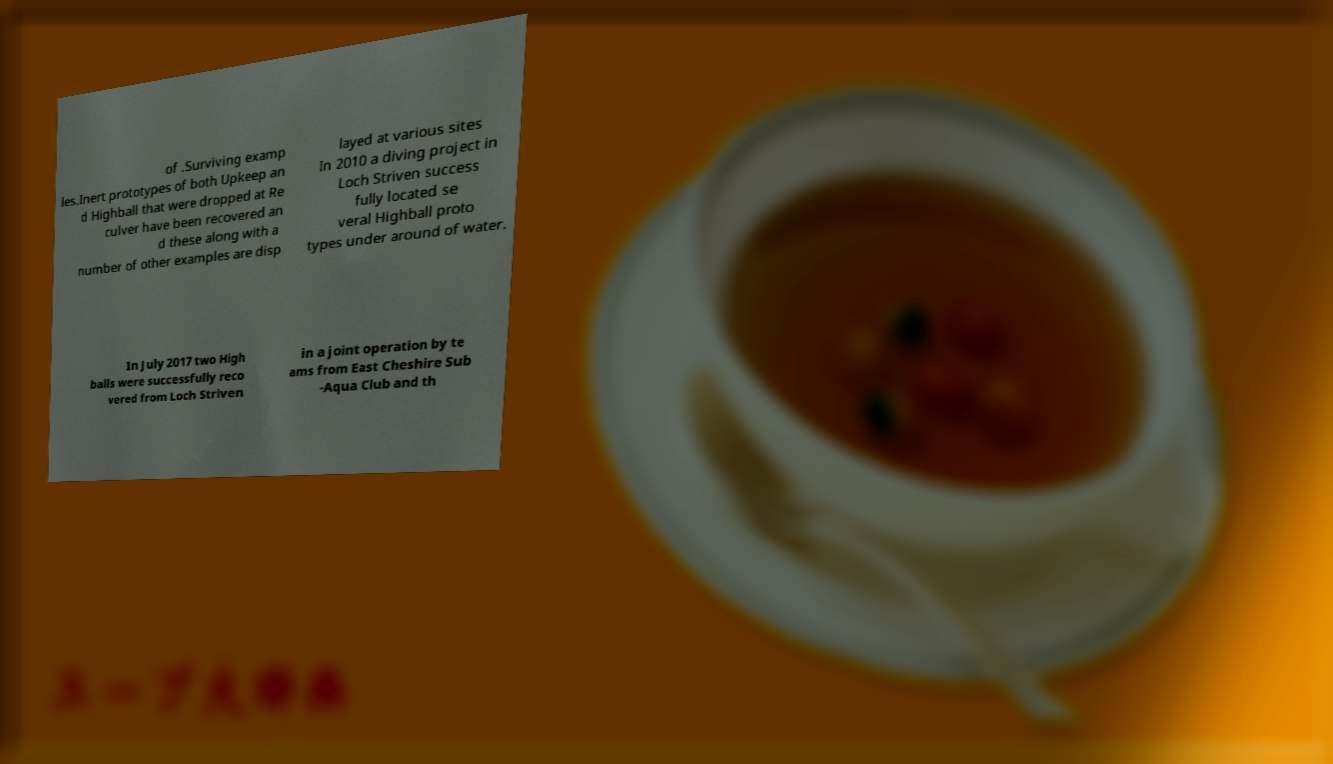Could you extract and type out the text from this image? of .Surviving examp les.Inert prototypes of both Upkeep an d Highball that were dropped at Re culver have been recovered an d these along with a number of other examples are disp layed at various sites In 2010 a diving project in Loch Striven success fully located se veral Highball proto types under around of water. In July 2017 two High balls were successfully reco vered from Loch Striven in a joint operation by te ams from East Cheshire Sub -Aqua Club and th 